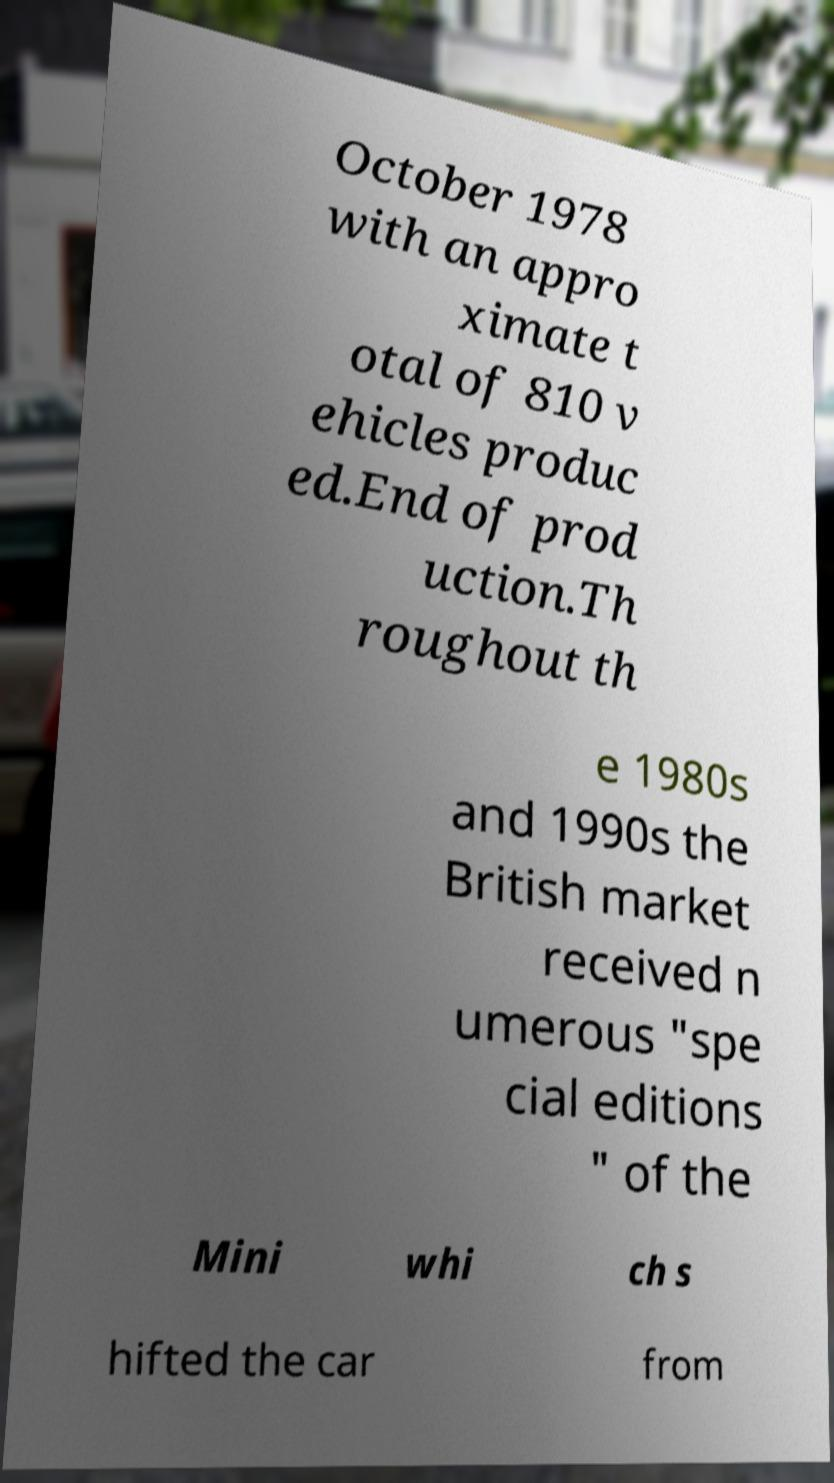Could you extract and type out the text from this image? October 1978 with an appro ximate t otal of 810 v ehicles produc ed.End of prod uction.Th roughout th e 1980s and 1990s the British market received n umerous "spe cial editions " of the Mini whi ch s hifted the car from 